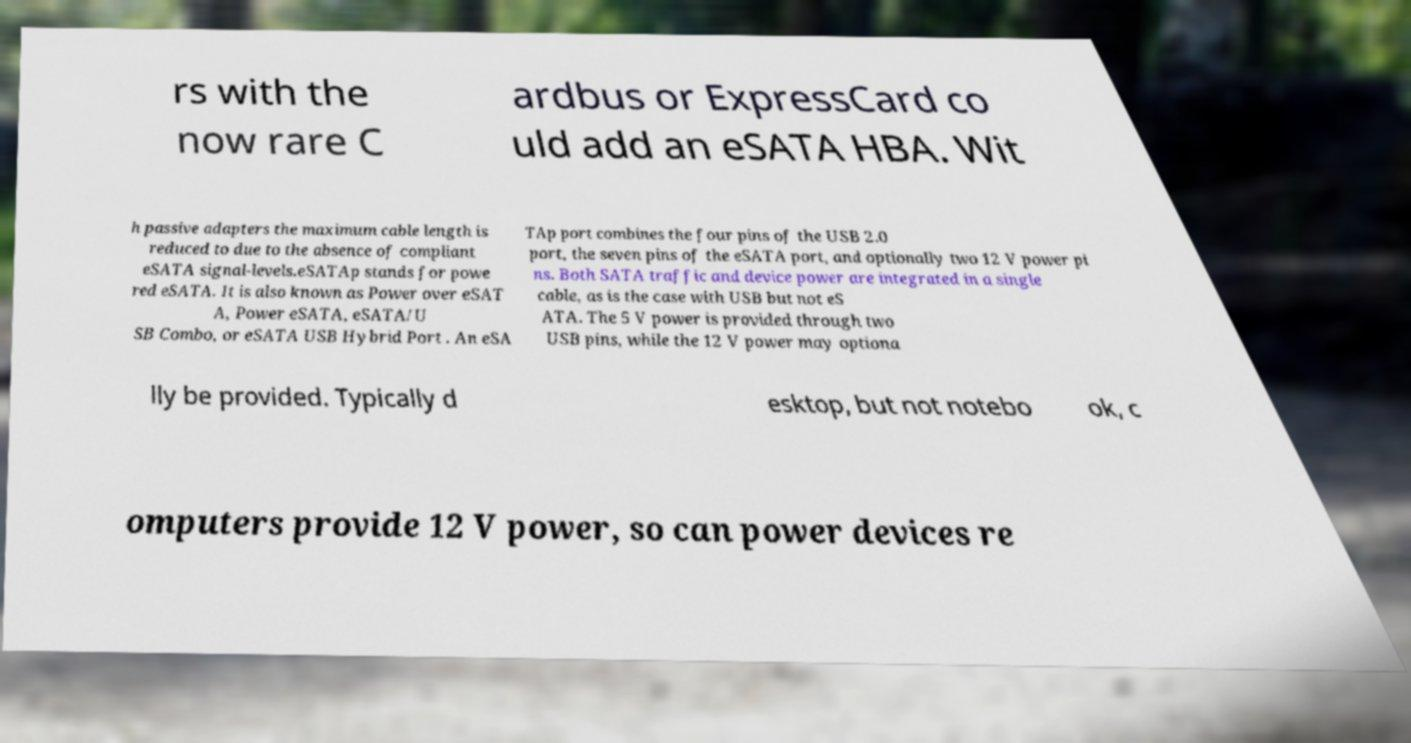What messages or text are displayed in this image? I need them in a readable, typed format. rs with the now rare C ardbus or ExpressCard co uld add an eSATA HBA. Wit h passive adapters the maximum cable length is reduced to due to the absence of compliant eSATA signal-levels.eSATAp stands for powe red eSATA. It is also known as Power over eSAT A, Power eSATA, eSATA/U SB Combo, or eSATA USB Hybrid Port . An eSA TAp port combines the four pins of the USB 2.0 port, the seven pins of the eSATA port, and optionally two 12 V power pi ns. Both SATA traffic and device power are integrated in a single cable, as is the case with USB but not eS ATA. The 5 V power is provided through two USB pins, while the 12 V power may optiona lly be provided. Typically d esktop, but not notebo ok, c omputers provide 12 V power, so can power devices re 